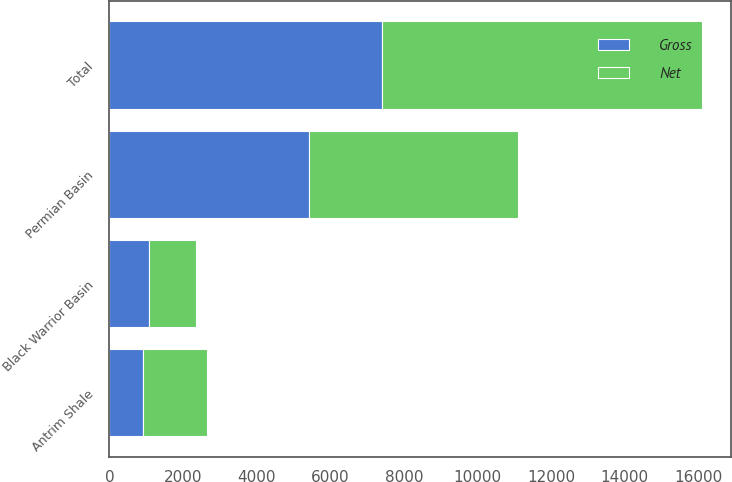Convert chart to OTSL. <chart><loc_0><loc_0><loc_500><loc_500><stacked_bar_chart><ecel><fcel>Permian Basin<fcel>Antrim Shale<fcel>Black Warrior Basin<fcel>Total<nl><fcel>Net<fcel>5664<fcel>1740<fcel>1289<fcel>8693<nl><fcel>Gross<fcel>5425<fcel>905<fcel>1064<fcel>7394<nl></chart> 